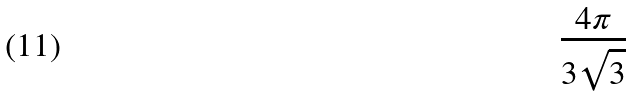Convert formula to latex. <formula><loc_0><loc_0><loc_500><loc_500>\frac { 4 \pi } { 3 \sqrt { 3 } }</formula> 